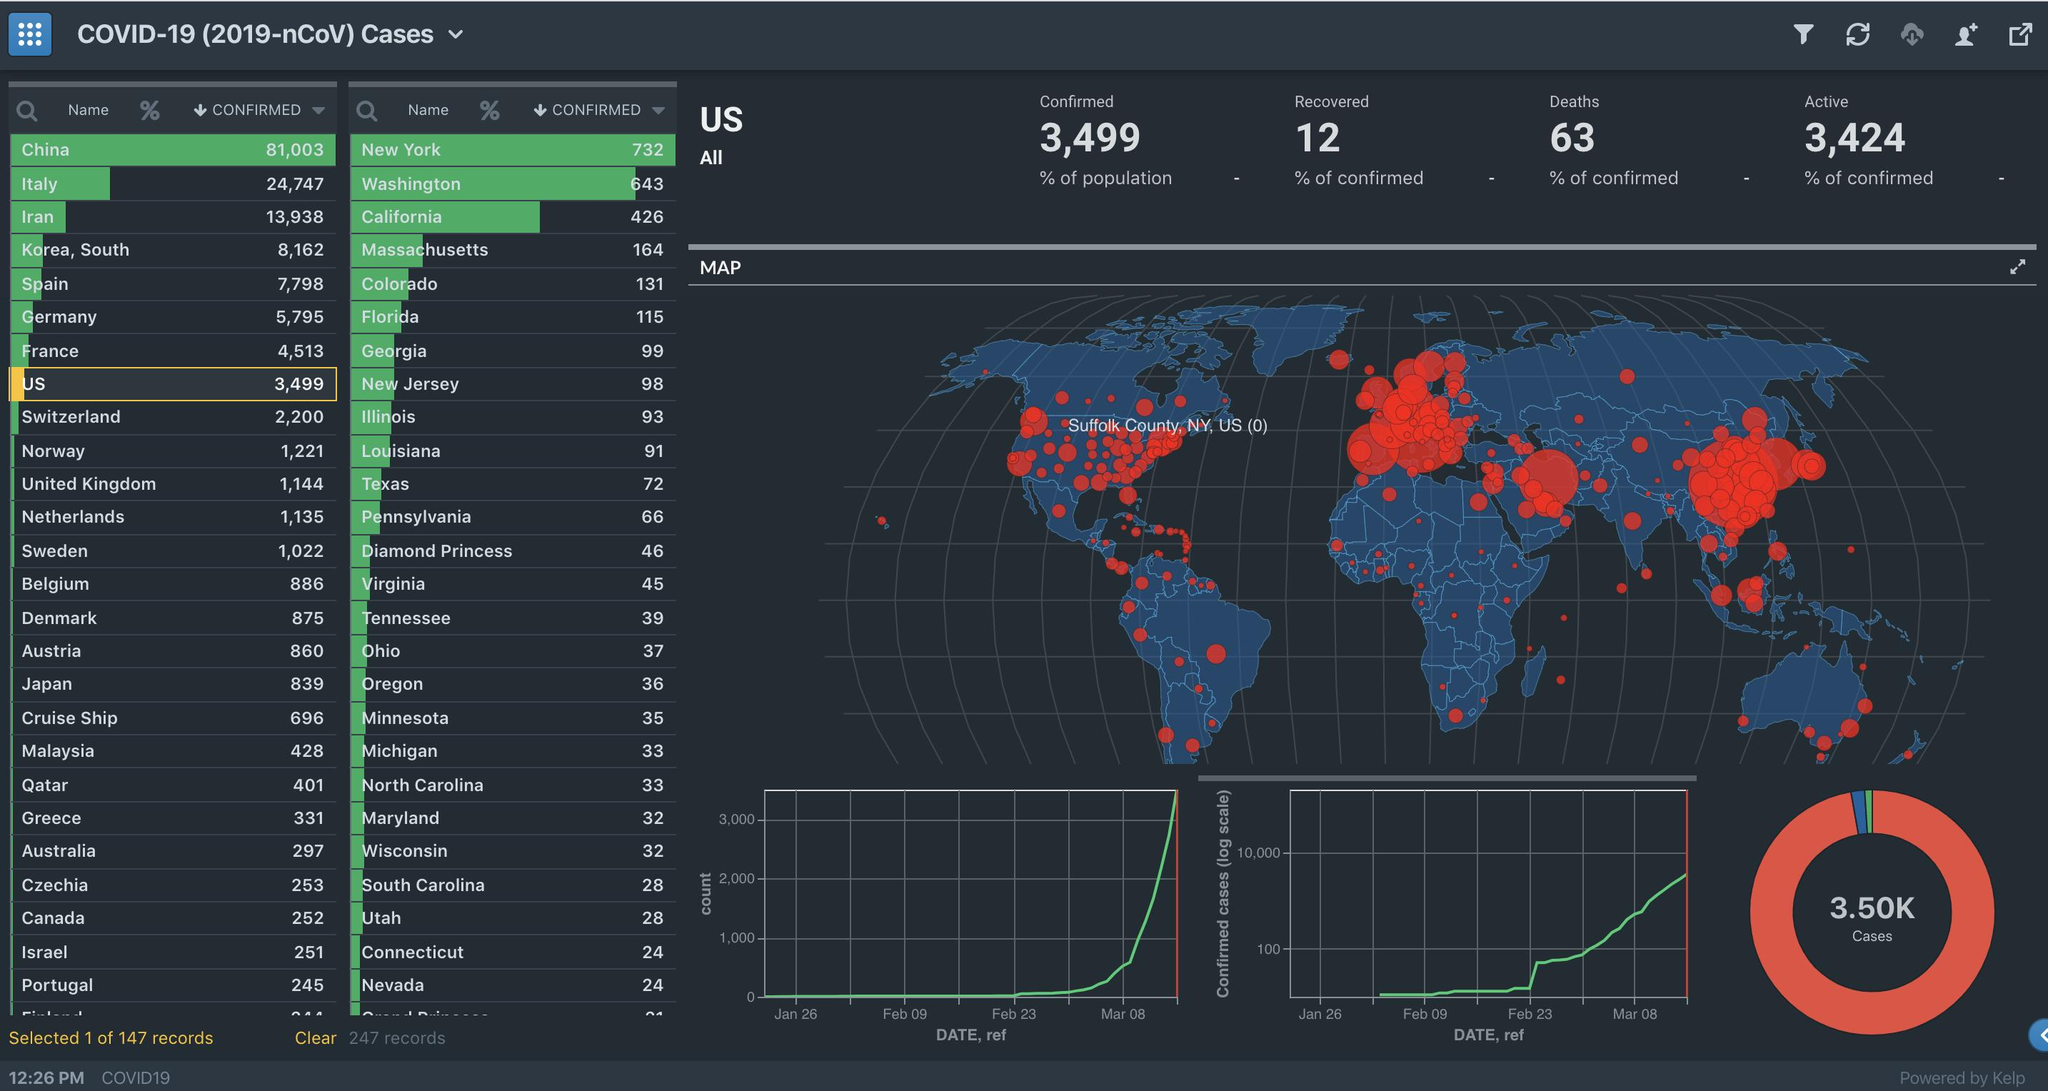Identify some key points in this picture. According to the infographic, two states have reported more than 500 COVID-19 cases. Florida has the sixth highest number of cases in the United States. According to the infographic, 12 states have reported more than 50 COVID-19 cases. Massachusetts has the fourth highest number of cases in the United States. Six states report more than a hundred COVID-19 cases, according to the infographic. 